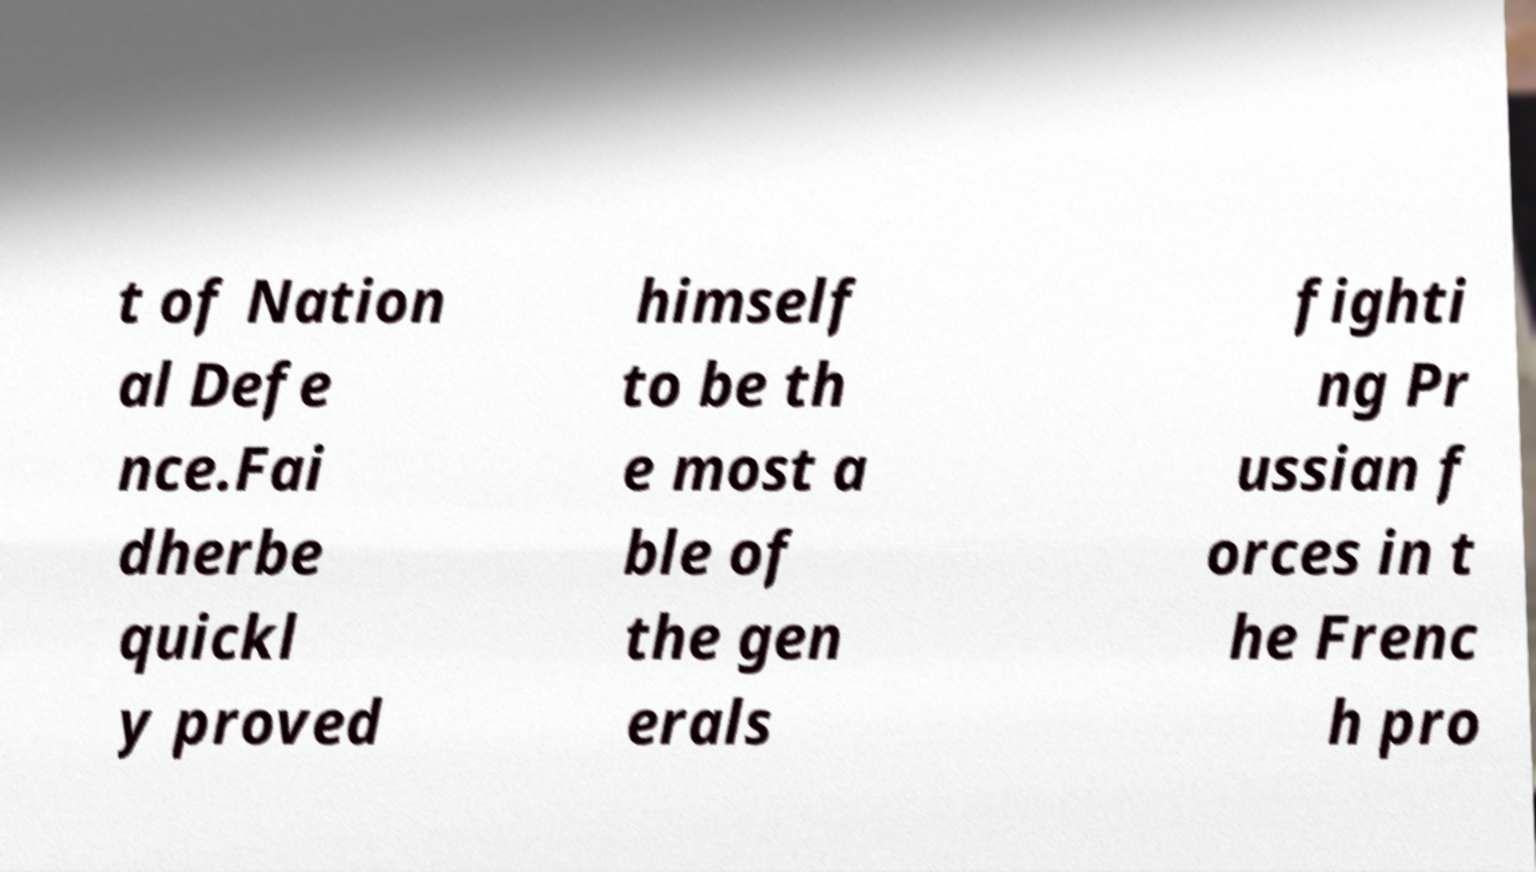Can you read and provide the text displayed in the image?This photo seems to have some interesting text. Can you extract and type it out for me? t of Nation al Defe nce.Fai dherbe quickl y proved himself to be th e most a ble of the gen erals fighti ng Pr ussian f orces in t he Frenc h pro 